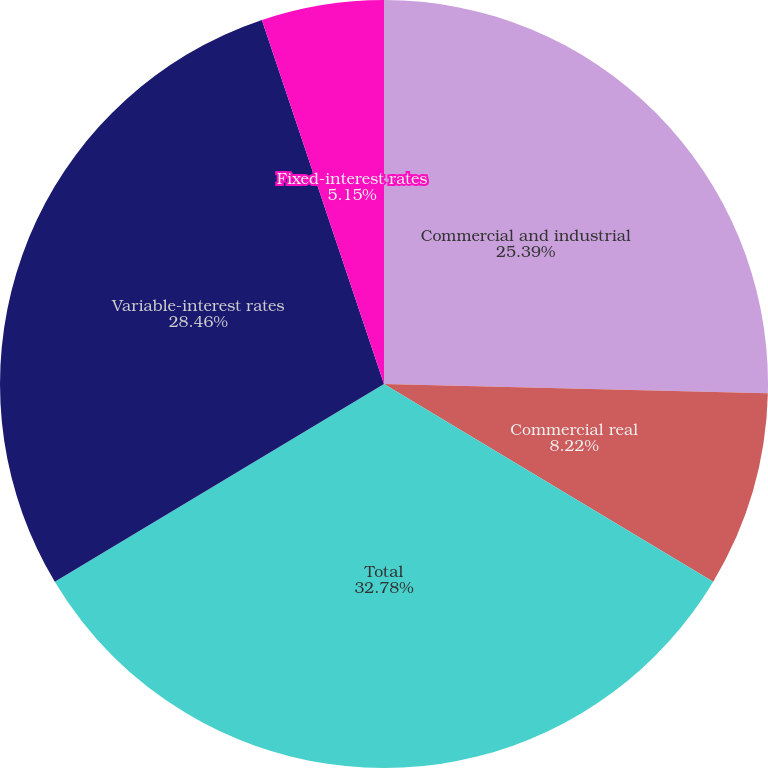<chart> <loc_0><loc_0><loc_500><loc_500><pie_chart><fcel>Commercial and industrial<fcel>Commercial real<fcel>Total<fcel>Variable-interest rates<fcel>Fixed-interest rates<nl><fcel>25.39%<fcel>8.22%<fcel>32.79%<fcel>28.46%<fcel>5.15%<nl></chart> 